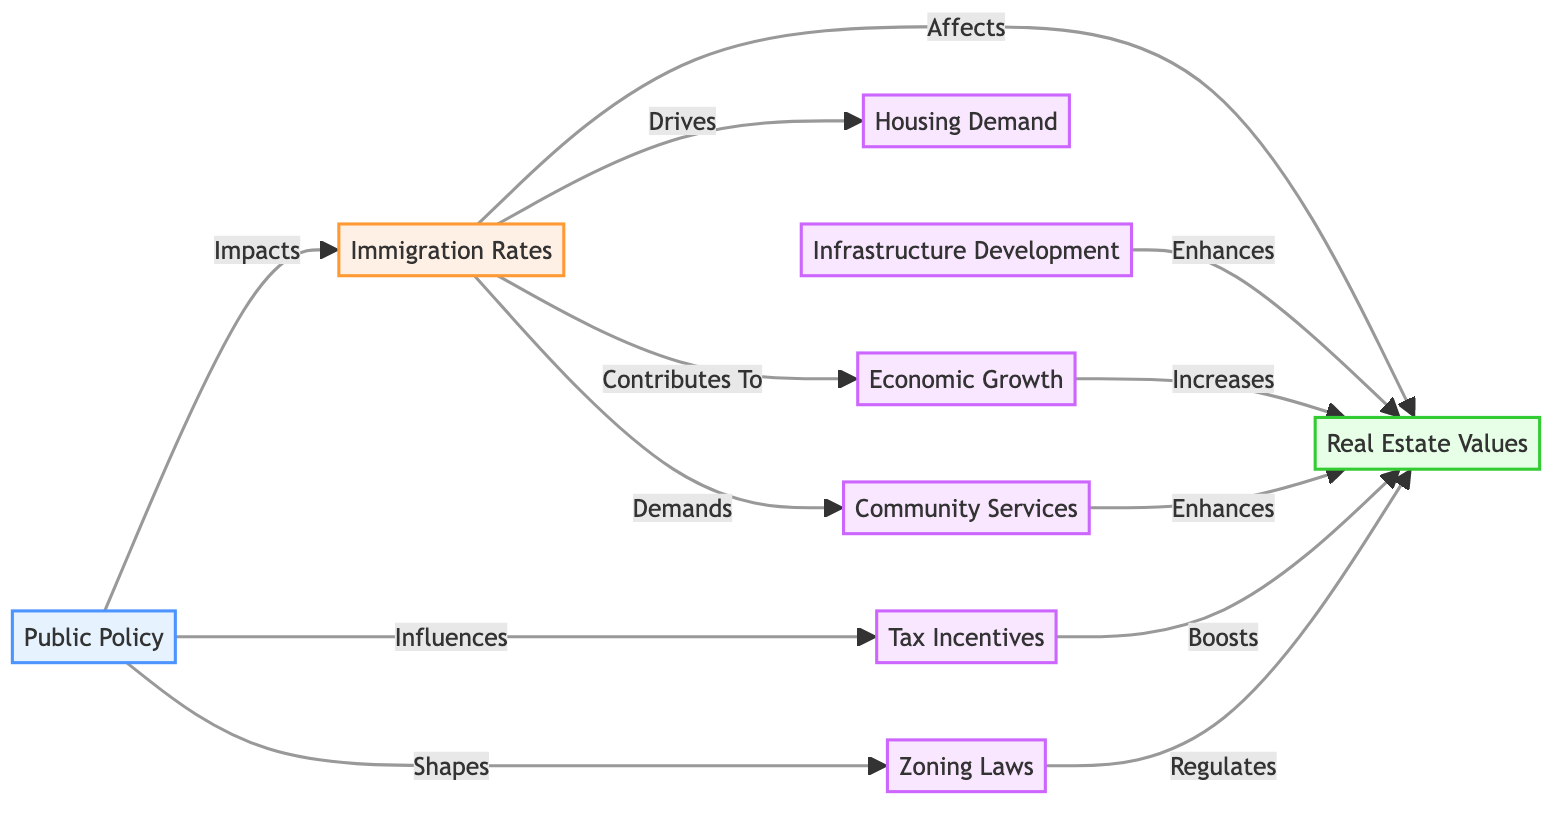What is the total number of nodes in the diagram? By counting the distinct nodes listed in the "nodes" section, we find 8 nodes: Public Policy, Immigration Rates, Real Estate Values, Tax Incentives, Zoning Laws, Infrastructure Development, Housing Demand, Economic Growth, and Community Services.
Answer: 8 Which node directly affects Real Estate Values? Looking at the edges connected to the Real Estate Values node, we find that Immigration Rates, Zoning Laws, Tax Incentives, Infrastructure Development, Economic Growth, and Community Services all affect Real Estate Values directly.
Answer: Immigration Rates, Zoning Laws, Tax Incentives, Infrastructure Development, Economic Growth, Community Services What is the relationship between Immigration Rates and Housing Demand? The edge labeled "Drives" connects Immigration Rates to Housing Demand, indicating that changes in Immigration Rates will influence or drive changes in Housing Demand.
Answer: Drives How many edges are connected to the Public Policy node? By counting the edges originating from the Public Policy node, we identify 3 edges: impacting Immigration Rates, influencing Tax Incentives, and shaping Zoning Laws.
Answer: 3 Which node contributes to Economic Growth? The diagram shows that Immigration Rates contribute to Economic Growth through the directed edge labeled "Contributes To".
Answer: Immigration Rates What are the two nodes connected to Real Estate Values that enhance its value? The edges connecting to Real Estate Values indicate that both Infrastructure Development and Community Services have a relationship that enhances the value of Real Estate.
Answer: Infrastructure Development, Community Services Which policy influences Tax Incentives? The edge labeled "Influences" indicates that Public Policy has an impact on Tax Incentives, suggesting that changes in Public Policy will affect Tax Incentives.
Answer: Public Policy What is the flow direction from Economic Growth to Real Estate Values? The relationship is represented by the edge labeled "Increases", which shows that Economic Growth has a positive influence on Real Estate Values, flowing from Economic Growth to Real Estate Values.
Answer: Increases How many distinct relationships are shown between Immigration Rates and other nodes in this diagram? Counting the edges originating from Immigration Rates, we find it connects to 4 different nodes: Real Estate Values, Housing Demand, Economic Growth, and Community Services.
Answer: 4 